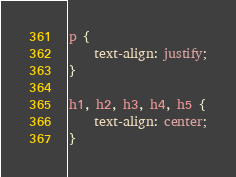Convert code to text. <code><loc_0><loc_0><loc_500><loc_500><_CSS_>p {
    text-align: justify;
}

h1, h2, h3, h4, h5 {
    text-align: center;
}
</code> 